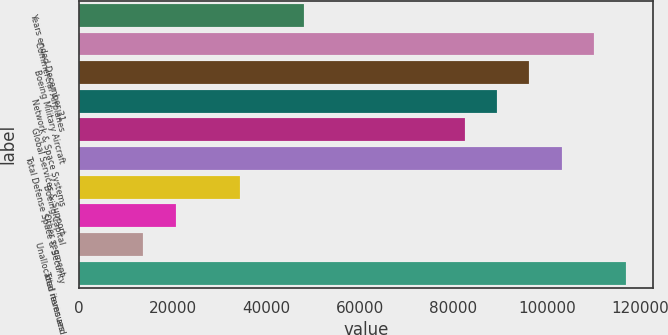Convert chart. <chart><loc_0><loc_0><loc_500><loc_500><bar_chart><fcel>Years ended December 31<fcel>Commercial Airplanes<fcel>Boeing Military Aircraft<fcel>Network & Space Systems<fcel>Global Services & Support<fcel>Total Defense Space & Security<fcel>Boeing Capital<fcel>Other segment<fcel>Unallocated items and<fcel>Total revenues<nl><fcel>48116.6<fcel>109972<fcel>96226.2<fcel>89353.4<fcel>82480.6<fcel>103099<fcel>34371<fcel>20625.4<fcel>13752.6<fcel>116845<nl></chart> 